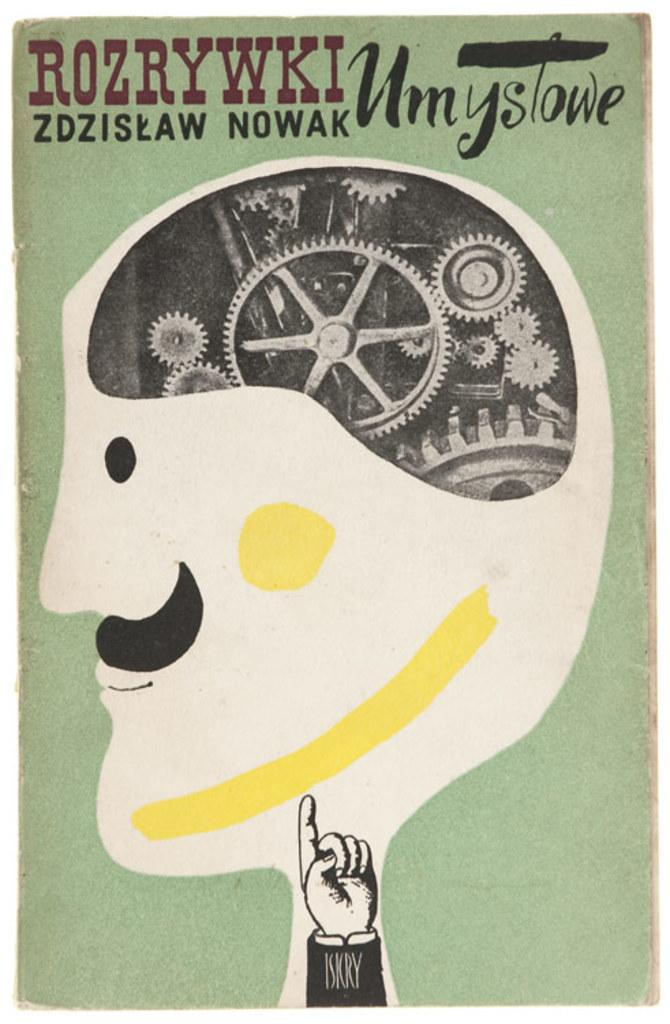<image>
Summarize the visual content of the image. a piece of artwork depicting a man's head and the gears inside the brain entitled ROZRYWKI Umyslowe. 